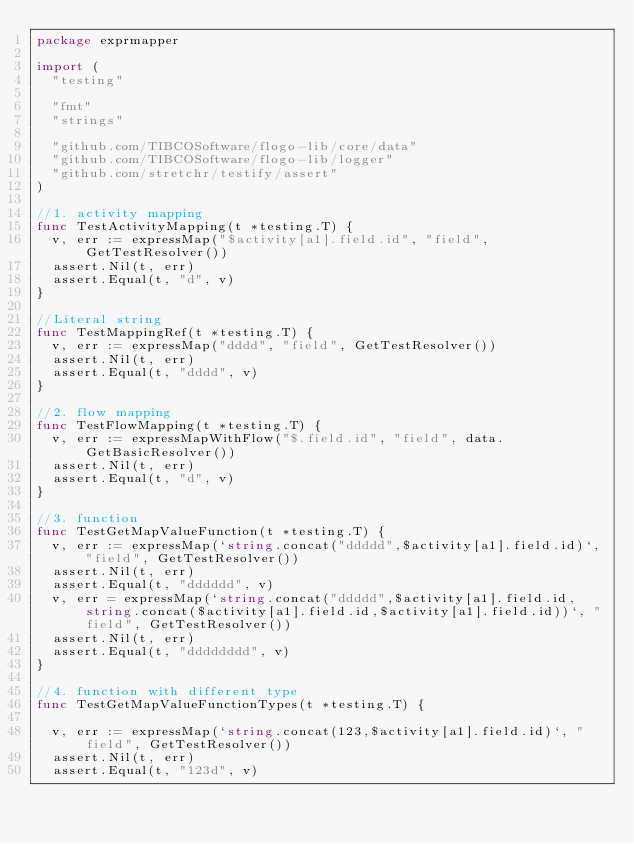<code> <loc_0><loc_0><loc_500><loc_500><_Go_>package exprmapper

import (
	"testing"

	"fmt"
	"strings"

	"github.com/TIBCOSoftware/flogo-lib/core/data"
	"github.com/TIBCOSoftware/flogo-lib/logger"
	"github.com/stretchr/testify/assert"
)

//1. activity mapping
func TestActivityMapping(t *testing.T) {
	v, err := expressMap("$activity[a1].field.id", "field", GetTestResolver())
	assert.Nil(t, err)
	assert.Equal(t, "d", v)
}

//Literal string
func TestMappingRef(t *testing.T) {
	v, err := expressMap("dddd", "field", GetTestResolver())
	assert.Nil(t, err)
	assert.Equal(t, "dddd", v)
}

//2. flow mapping
func TestFlowMapping(t *testing.T) {
	v, err := expressMapWithFlow("$.field.id", "field", data.GetBasicResolver())
	assert.Nil(t, err)
	assert.Equal(t, "d", v)
}

//3. function
func TestGetMapValueFunction(t *testing.T) {
	v, err := expressMap(`string.concat("ddddd",$activity[a1].field.id)`, "field", GetTestResolver())
	assert.Nil(t, err)
	assert.Equal(t, "dddddd", v)
	v, err = expressMap(`string.concat("ddddd",$activity[a1].field.id, string.concat($activity[a1].field.id,$activity[a1].field.id))`, "field", GetTestResolver())
	assert.Nil(t, err)
	assert.Equal(t, "dddddddd", v)
}

//4. function with different type
func TestGetMapValueFunctionTypes(t *testing.T) {

	v, err := expressMap(`string.concat(123,$activity[a1].field.id)`, "field", GetTestResolver())
	assert.Nil(t, err)
	assert.Equal(t, "123d", v)
</code> 